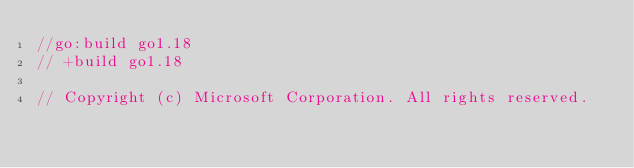Convert code to text. <code><loc_0><loc_0><loc_500><loc_500><_Go_>//go:build go1.18
// +build go1.18

// Copyright (c) Microsoft Corporation. All rights reserved.</code> 